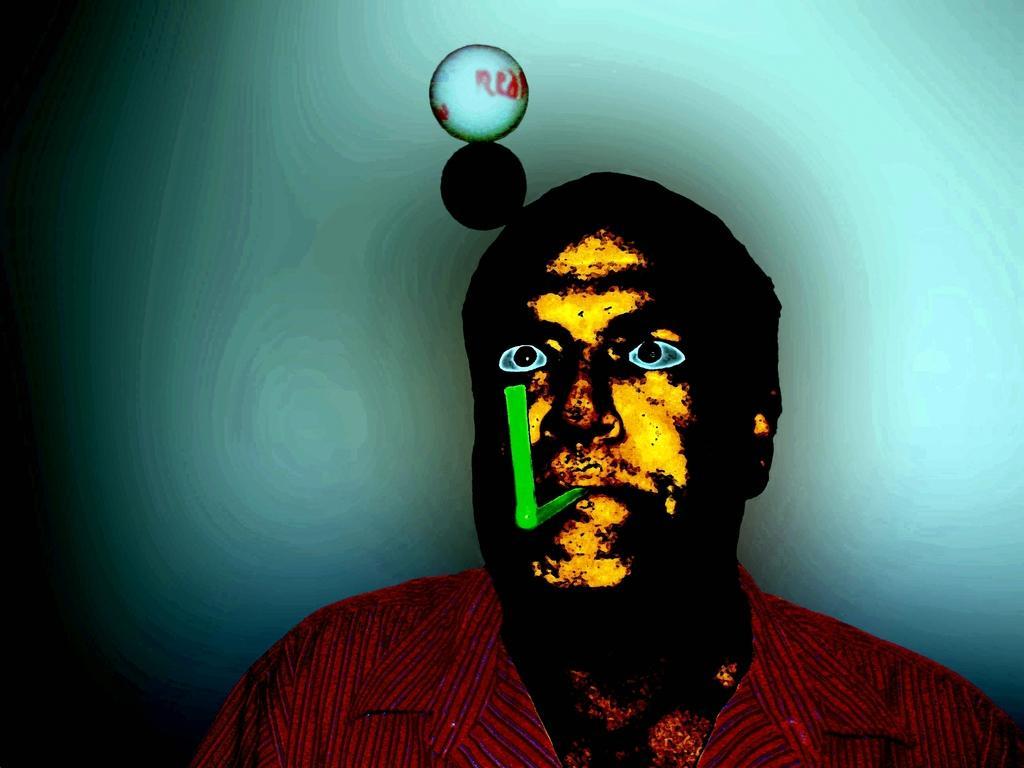In one or two sentences, can you explain what this image depicts? In this image I can see it is an edited image, in the middle there is a man, he is wearing a shirt and here it looks like a plastic thing in his mouth. 